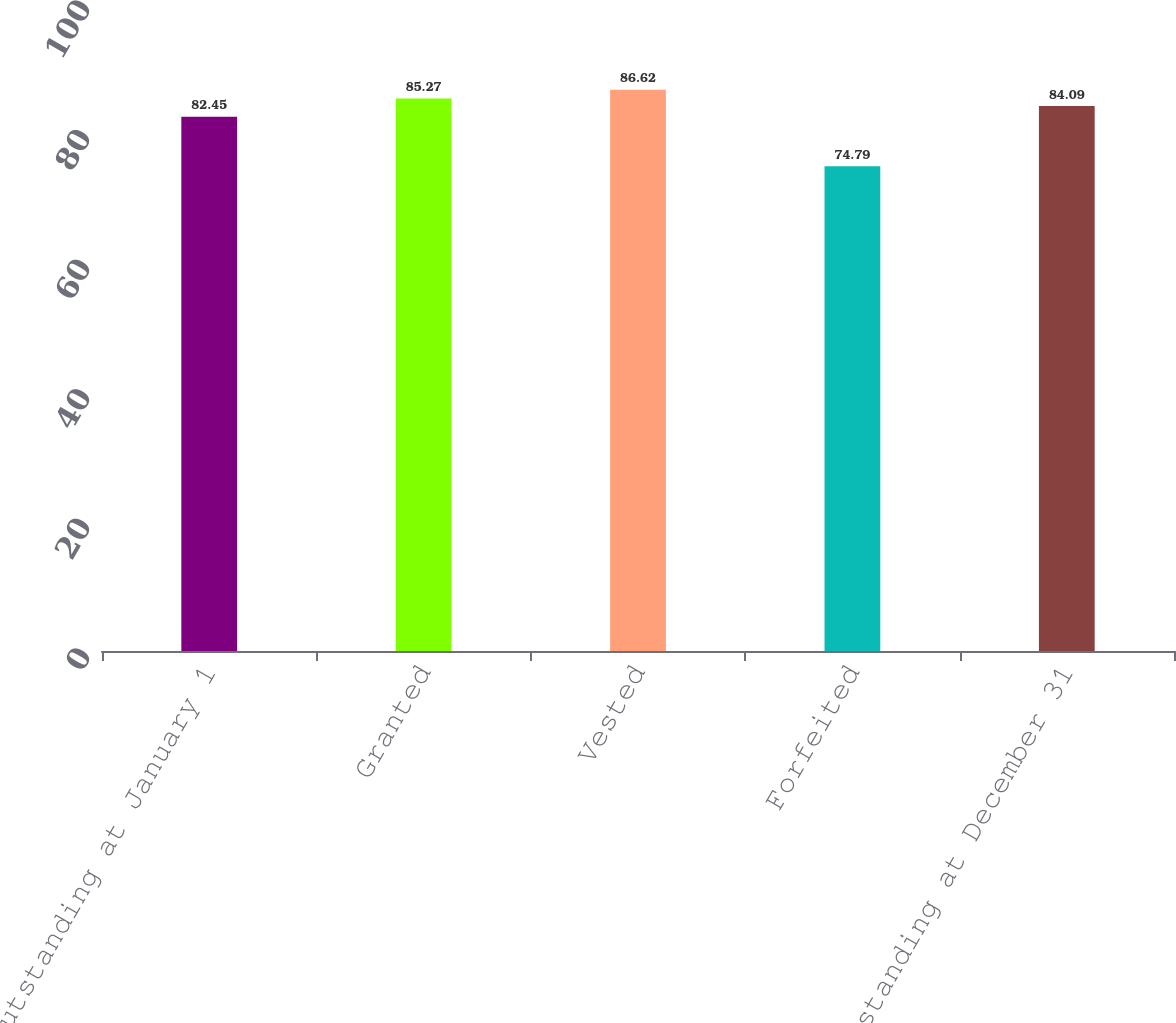Convert chart to OTSL. <chart><loc_0><loc_0><loc_500><loc_500><bar_chart><fcel>Outstanding at January 1<fcel>Granted<fcel>Vested<fcel>Forfeited<fcel>Outstanding at December 31<nl><fcel>82.45<fcel>85.27<fcel>86.62<fcel>74.79<fcel>84.09<nl></chart> 